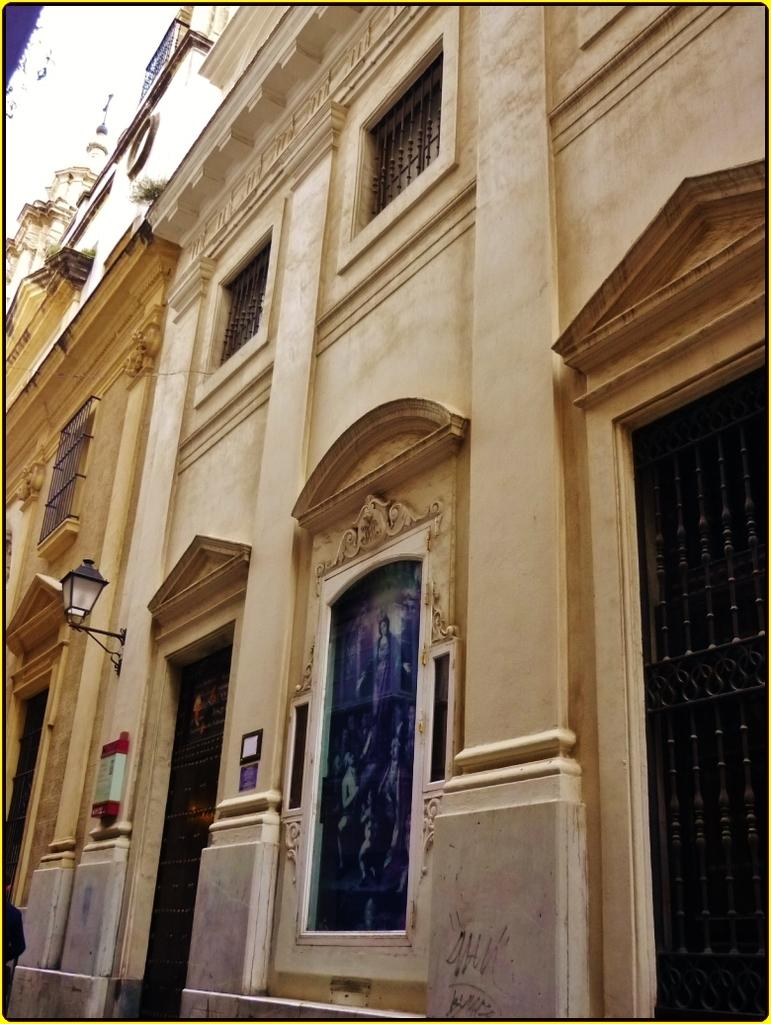What type of structure is in the image? There is a big building in the image. What feature can be seen on the building? The building has glass windows. What else is visible on the building? There is light on the wall of the building. What type of jelly can be seen on the door of the building in the image? There is no door or jelly present in the image; it only shows a big building with glass windows and light on the wall. 